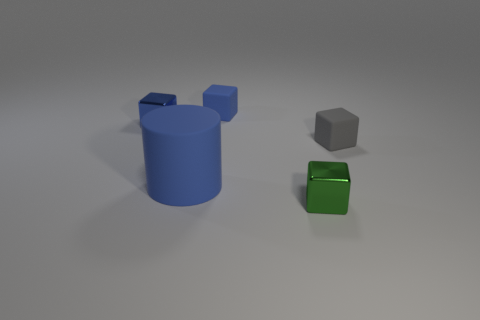Are there any other things that have the same size as the cylinder?
Provide a short and direct response. No. What number of objects are either small blocks or objects in front of the blue metal block?
Offer a very short reply. 5. Are there the same number of small shiny objects that are right of the small green block and blue objects?
Give a very brief answer. No. There is a gray thing that is the same material as the big blue object; what is its shape?
Your response must be concise. Cube. Are there any small cubes that have the same color as the large cylinder?
Ensure brevity in your answer.  Yes. How many matte objects are tiny gray cylinders or large blue cylinders?
Your answer should be very brief. 1. There is a small metallic object in front of the big blue cylinder; what number of small green shiny things are left of it?
Your answer should be compact. 0. How many yellow blocks have the same material as the gray thing?
Give a very brief answer. 0. How many big things are either blue rubber objects or shiny blocks?
Your answer should be very brief. 1. There is a tiny thing that is behind the green object and in front of the small blue shiny cube; what shape is it?
Ensure brevity in your answer.  Cube. 